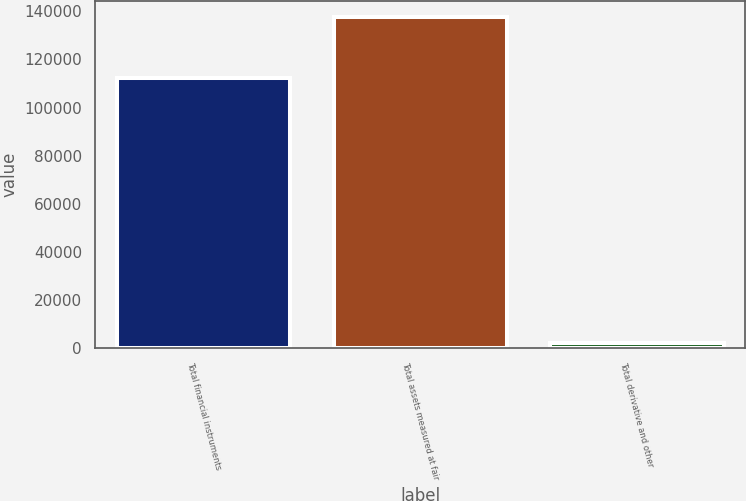<chart> <loc_0><loc_0><loc_500><loc_500><bar_chart><fcel>Total financial instruments<fcel>Total assets measured at fair<fcel>Total derivative and other<nl><fcel>112408<fcel>137375<fcel>2105<nl></chart> 